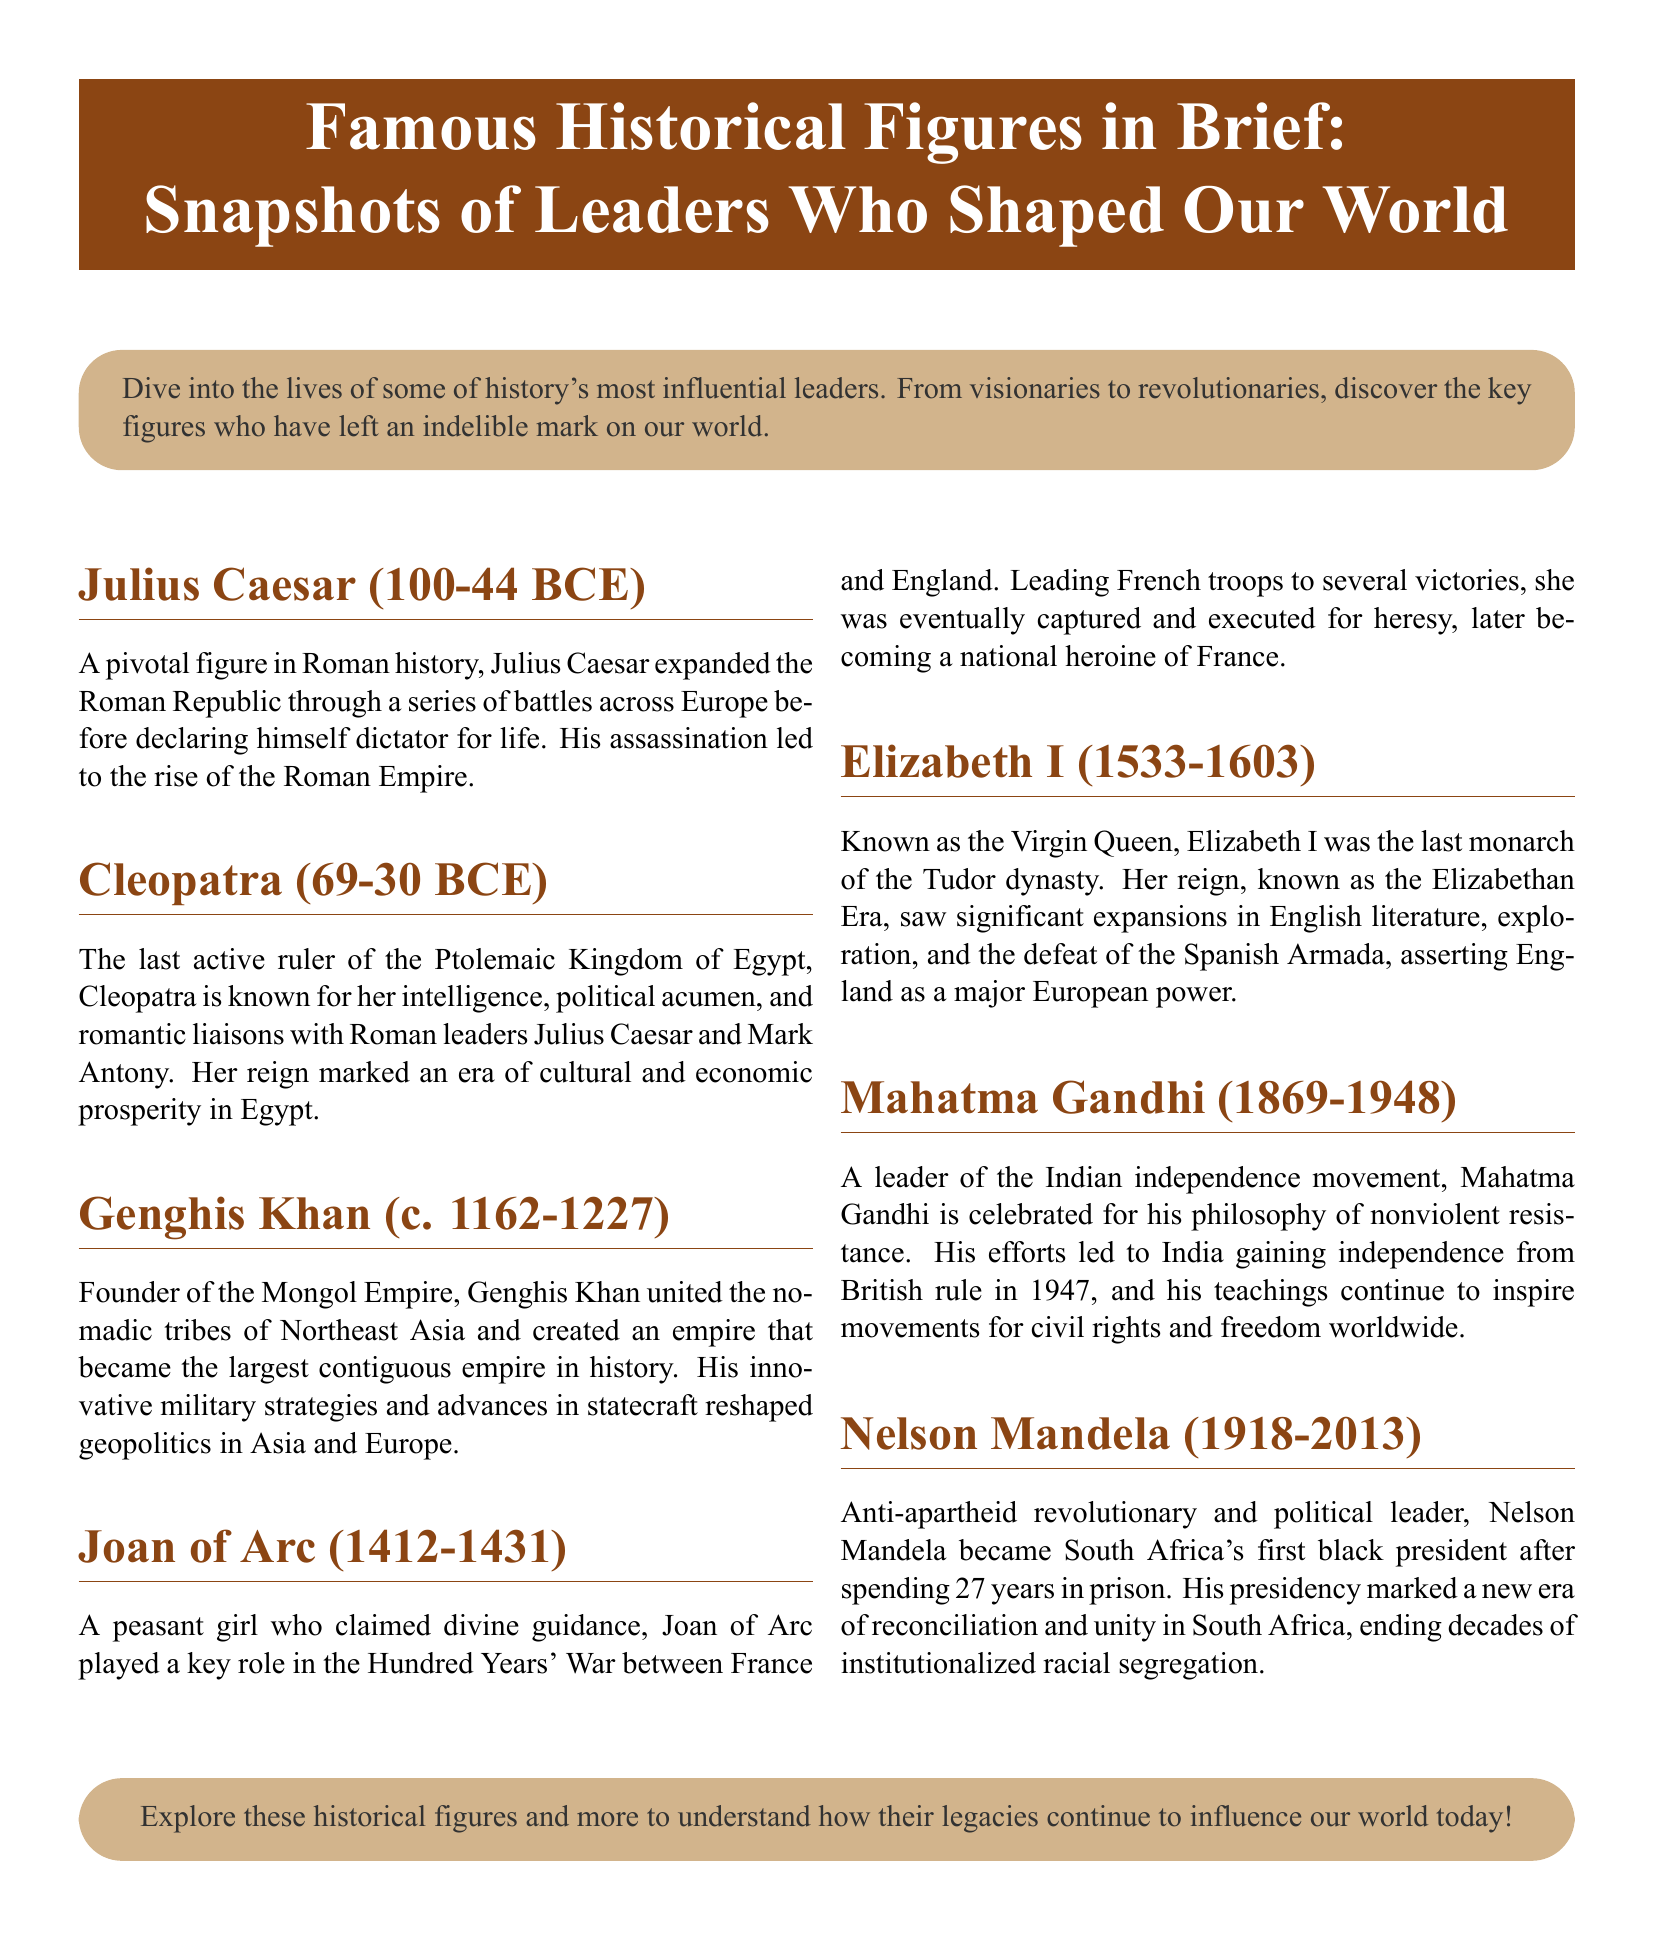What year was Julius Caesar born? The document states that Julius Caesar was born in 100 BCE.
Answer: 100 BCE Who was the last ruler of the Ptolemaic Kingdom of Egypt? Cleopatra is identified in the document as the last active ruler of the Ptolemaic Kingdom of Egypt.
Answer: Cleopatra Which empire did Genghis Khan found? The document specifies that Genghis Khan founded the Mongol Empire.
Answer: Mongol Empire What is Mahatma Gandhi known for? The document highlights that Mahatma Gandhi is celebrated for his philosophy of nonviolent resistance.
Answer: Nonviolent resistance How long did Nelson Mandela spend in prison? The document notes that Nelson Mandela spent 27 years in prison before becoming South Africa's first black president.
Answer: 27 years During which war did Joan of Arc claim divine guidance? The document mentions that Joan of Arc played a key role in the Hundred Years' War.
Answer: Hundred Years' War What significant event is associated with Elizabeth I's reign? The document states that Elizabeth I's reign saw the defeat of the Spanish Armada.
Answer: Defeat of the Spanish Armada What philosophy did Gandhi's efforts lead to in India? The document indicates that Gandhi's efforts led to India gaining independence from British rule.
Answer: Independence from British rule 